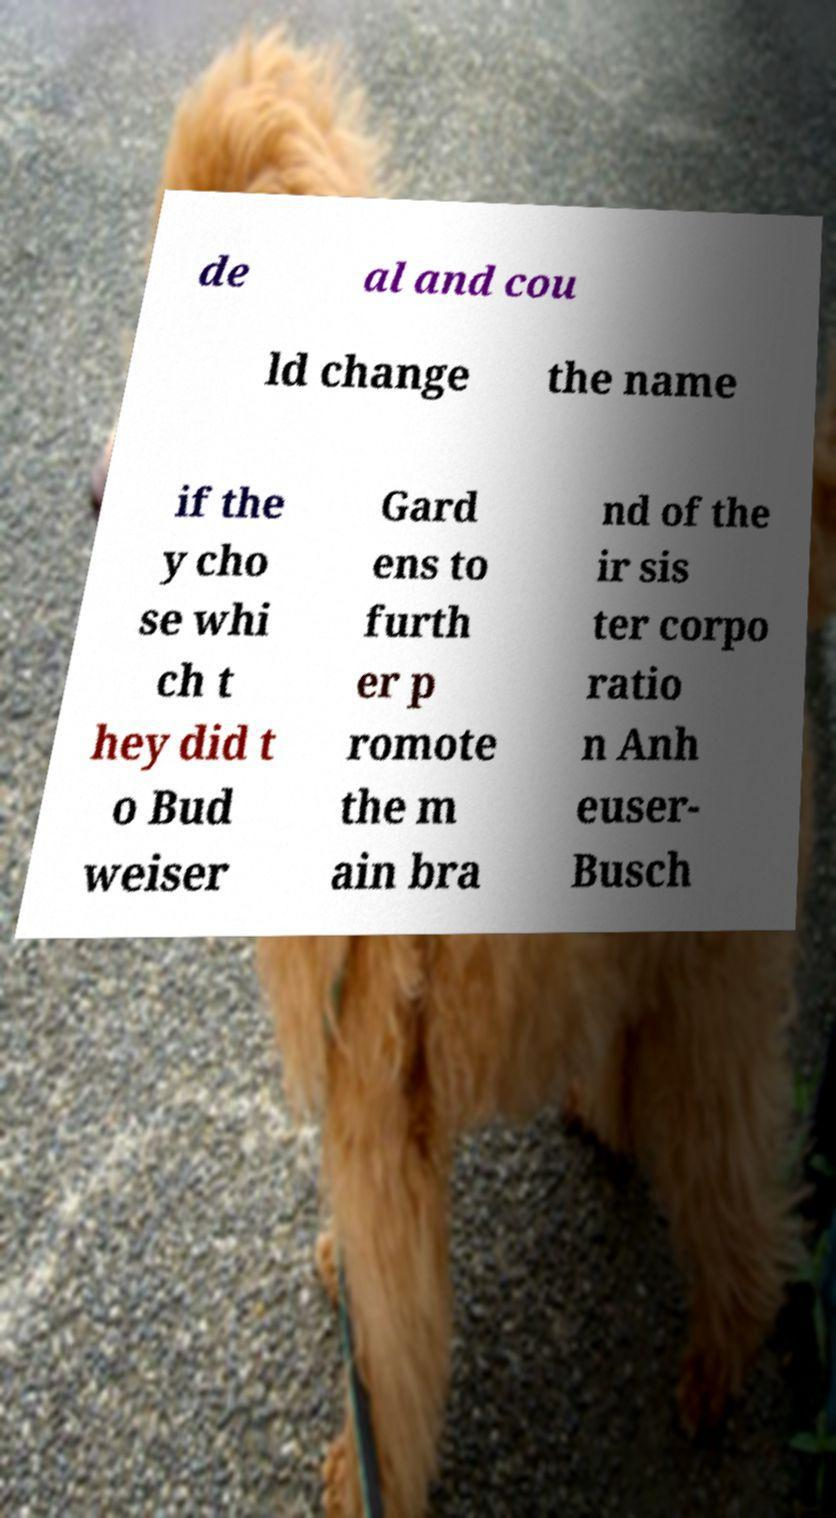Could you assist in decoding the text presented in this image and type it out clearly? de al and cou ld change the name if the y cho se whi ch t hey did t o Bud weiser Gard ens to furth er p romote the m ain bra nd of the ir sis ter corpo ratio n Anh euser- Busch 